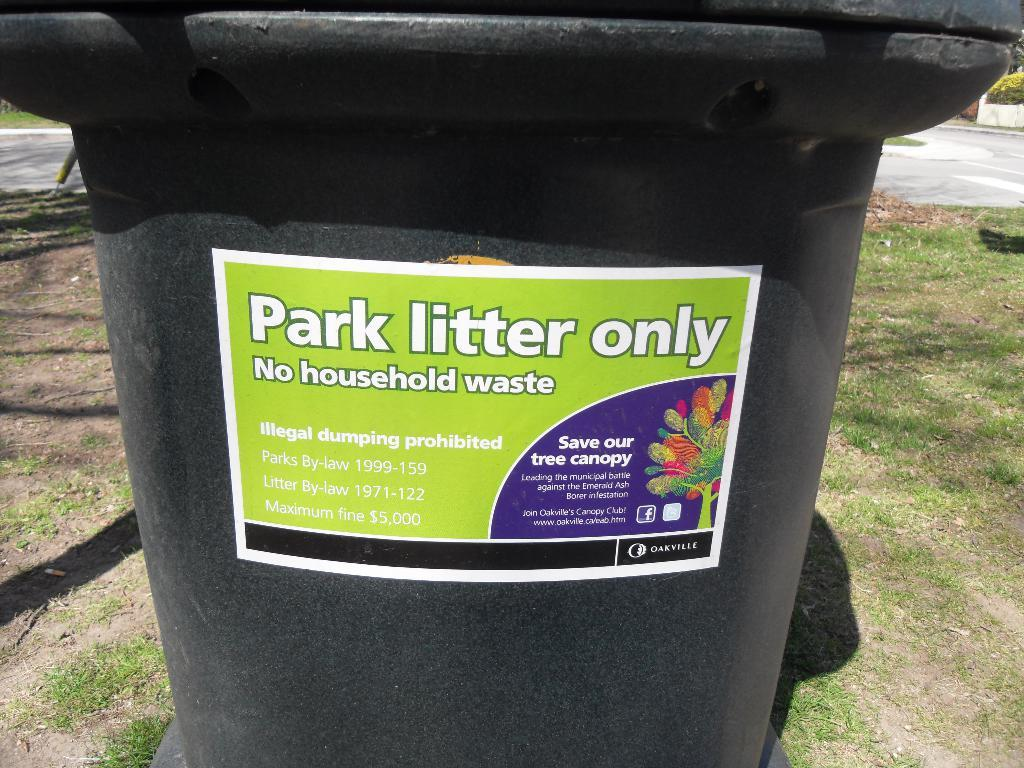What color is the dustbin in the image? The dustbin in the image is black. Is there any writing or image on the dustbin? Yes, there is a paper pasted on the dustbin. What can be seen in the background of the image? Grass is visible in the background of the image. How many points did the achiever score in the recess? There is no mention of an achiever or a recess in the image, so it is not possible to answer that question. 